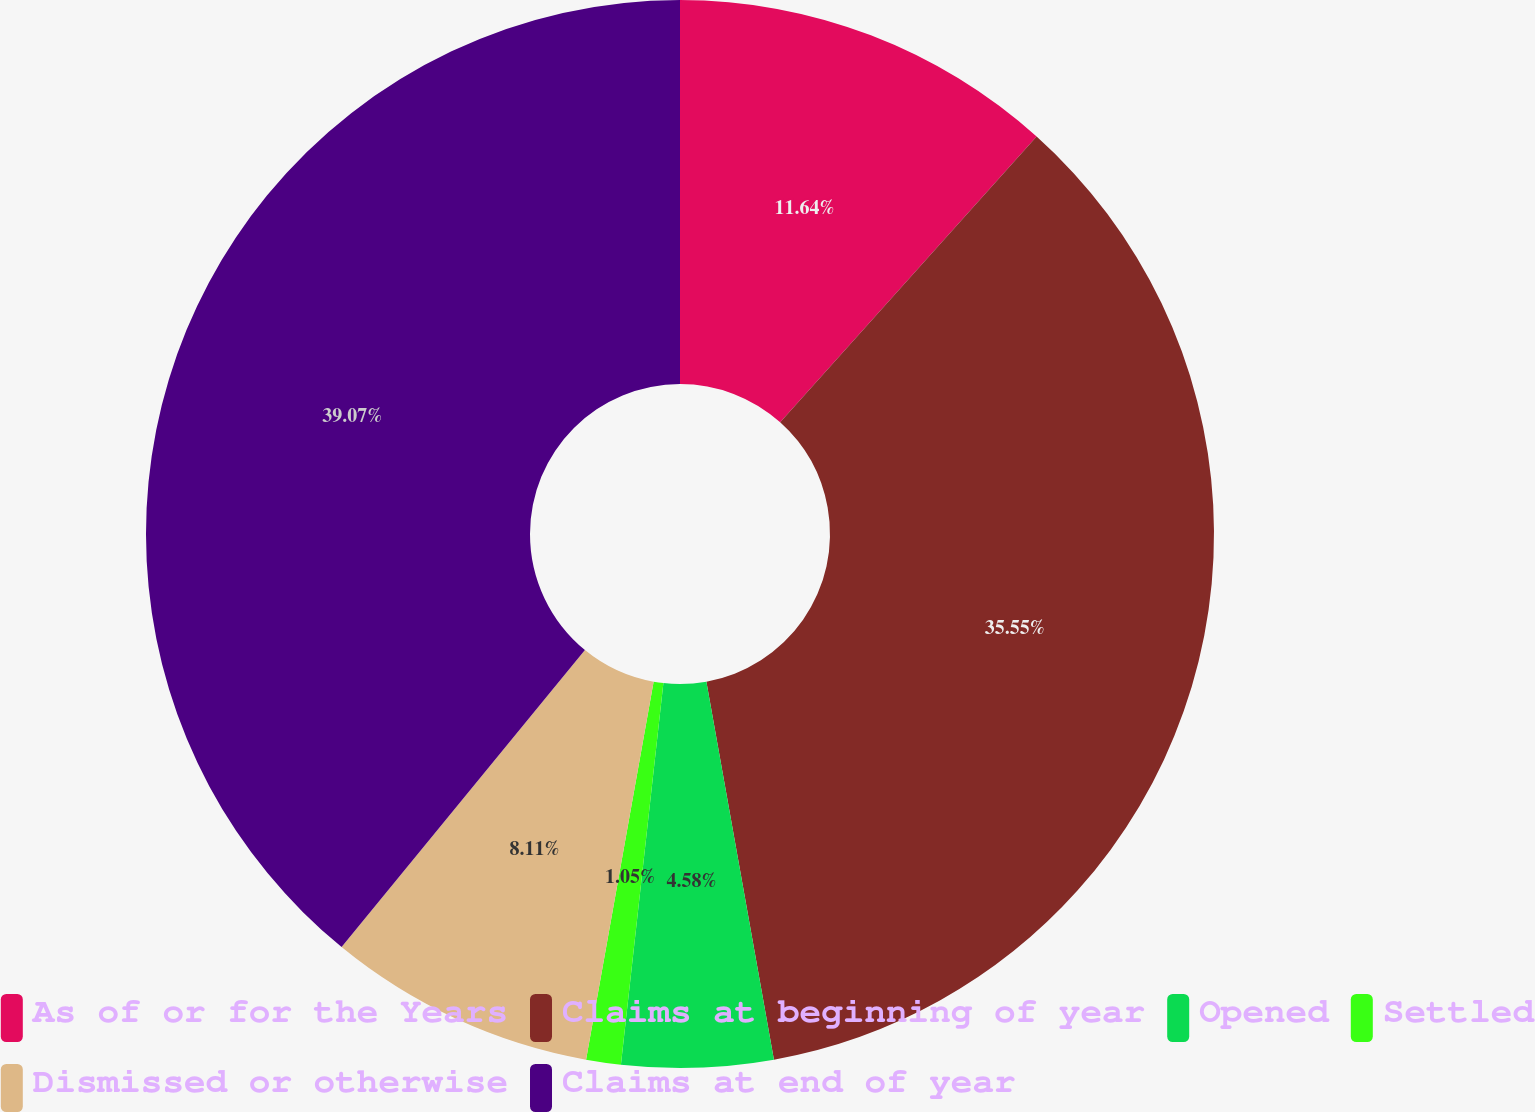<chart> <loc_0><loc_0><loc_500><loc_500><pie_chart><fcel>As of or for the Years<fcel>Claims at beginning of year<fcel>Opened<fcel>Settled<fcel>Dismissed or otherwise<fcel>Claims at end of year<nl><fcel>11.64%<fcel>35.55%<fcel>4.58%<fcel>1.05%<fcel>8.11%<fcel>39.08%<nl></chart> 